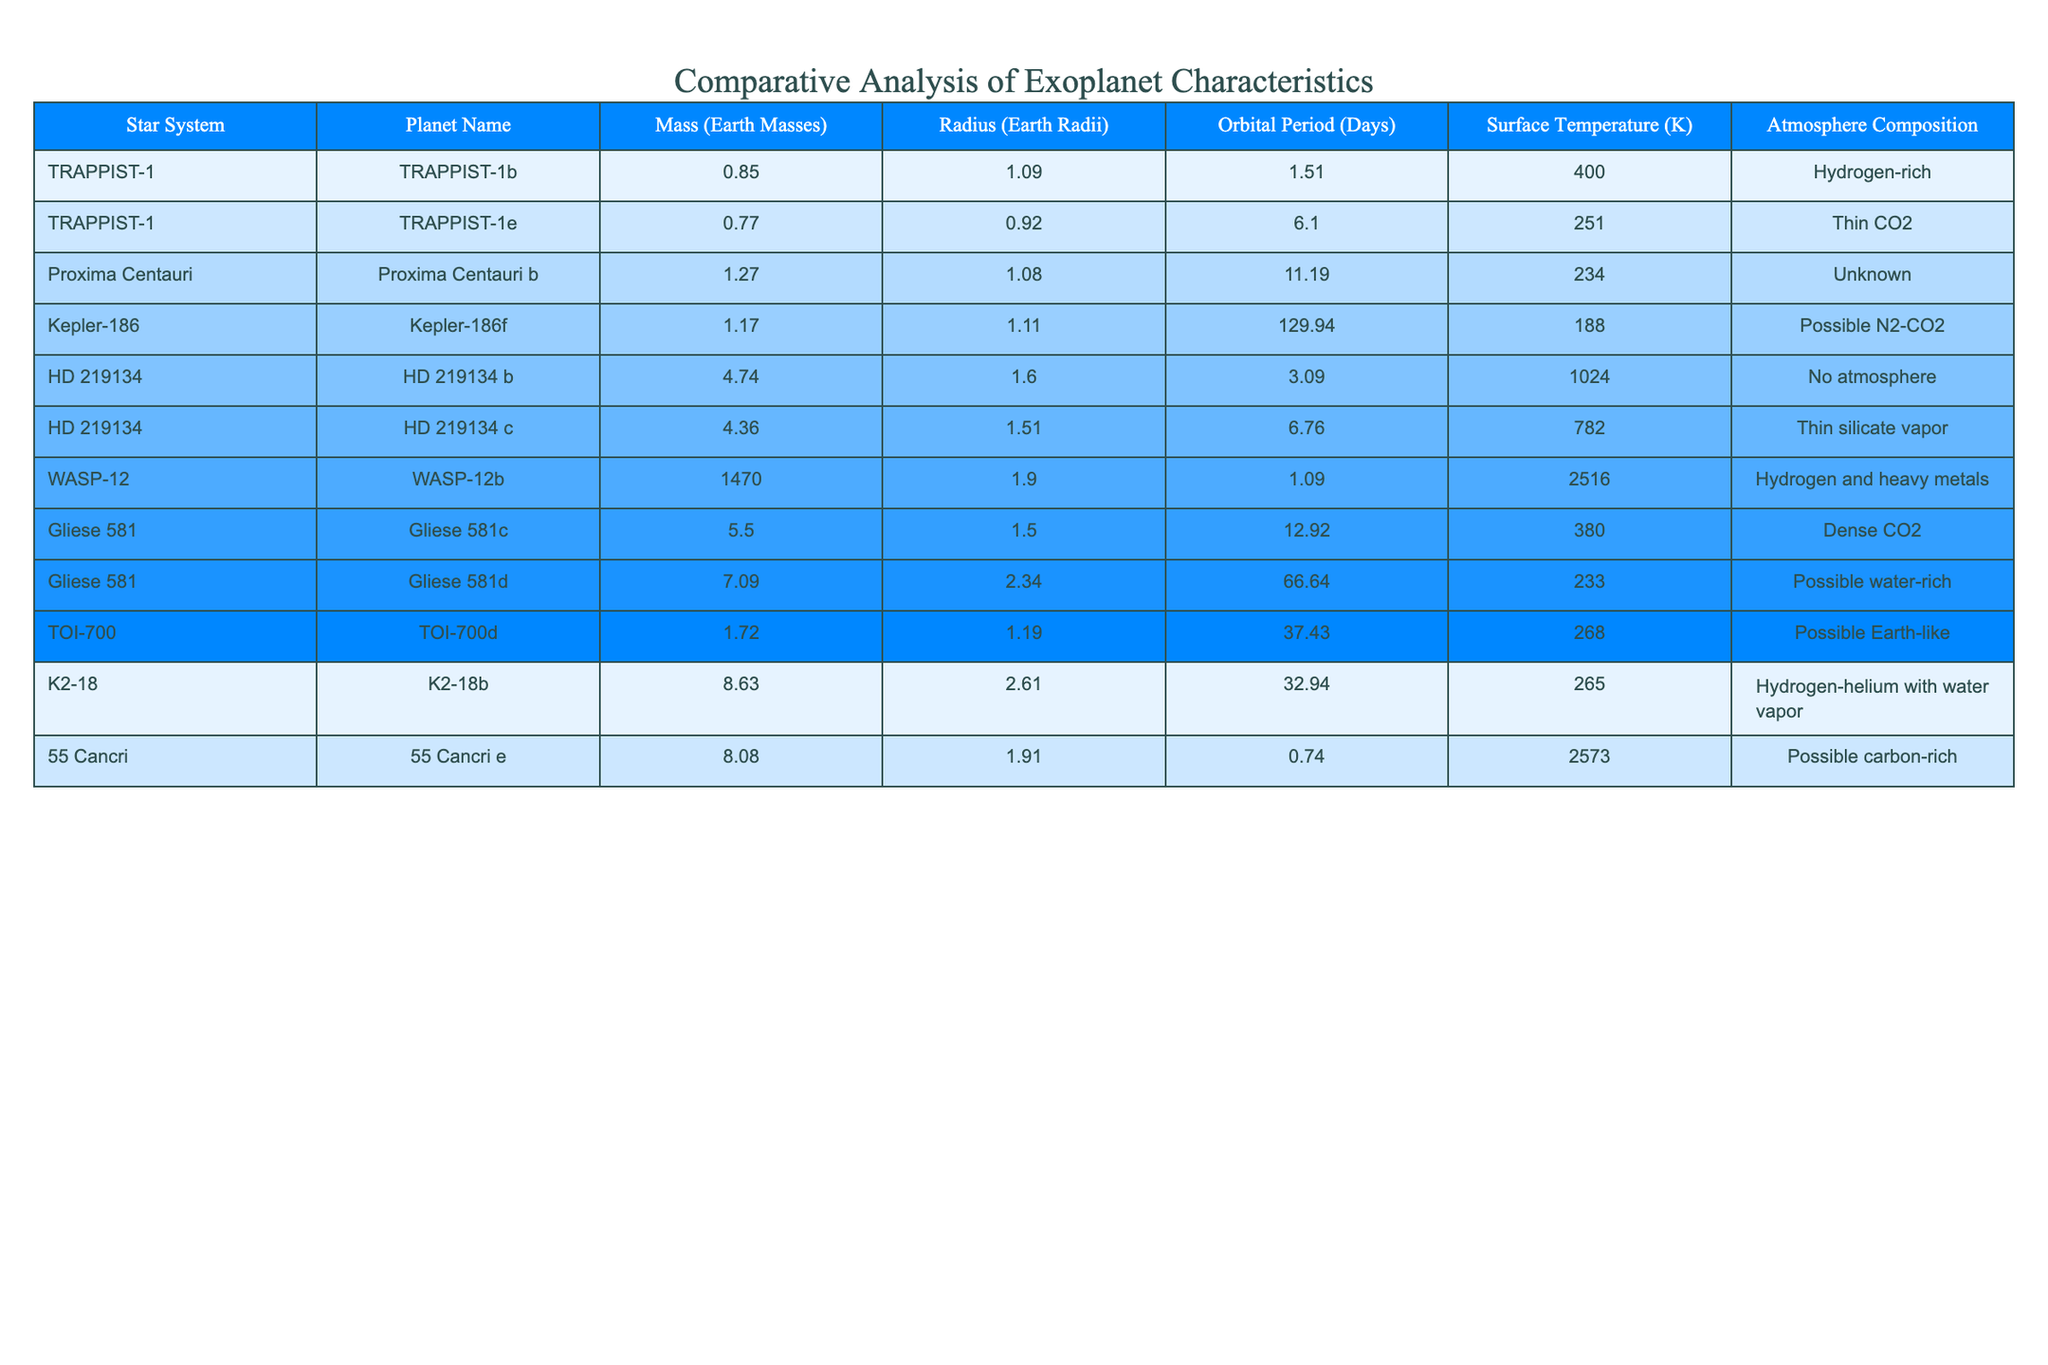What is the mass of Kepler-186f in Earth masses? The table lists the mass of Kepler-186f, which is found in the column labeled "Mass (Earth Masses)." The value corresponding to Kepler-186f is 1.17.
Answer: 1.17 What planet has the highest surface temperature? By examining the "Surface Temperature (K)" column in the table, we can see that the highest value is 2516 K, which corresponds to WASP-12b.
Answer: WASP-12b How many planets have a mass greater than 5 Earth masses? Counting the planets listed in the "Mass (Earth Masses)" column reveals that Gliese 581c, Gliese 581d, K2-18b, and 55 Cancri e all have mass values greater than 5, totaling 4 planets.
Answer: 4 What is the average orbital period of the planets listed? To find the average orbital period, we need to sum the "Orbital Period (Days)" values (1.51 + 6.10 + 11.19 + 129.94 + 3.09 + 6.76 + 1.09 + 12.92 + 66.64 + 37.43 + 0.74) and divide by the number of planets (11). The total is 275.97, and the average is 275.97 / 11 = 25.09 days.
Answer: 25.09 days Do all the planets in the HD 219134 system have a thick atmosphere? Looking at the "Atmosphere Composition" column for the HD 219134 b and c entries, we find that both have either no atmosphere or a thin atmosphere (silicate vapor), indicating they do not have a thick atmosphere.
Answer: No Which planet has the longest orbital period? The "Orbital Period (Days)" column reveals that Kepler-186f has the longest period at 129.94 days.
Answer: Kepler-186f What is the difference in surface temperature between TRAPPIST-1b and TRAPPIST-1e? The surface temperature for TRAPPIST-1b is 400 K and for TRAPPIST-1e is 251 K. The difference is 400 - 251 = 149 K.
Answer: 149 K Is there a planet with no atmosphere, and if so, which one? By checking the "Atmosphere Composition," we see that HD 219134 b has "No atmosphere."
Answer: Yes, HD 219134 b What are the compositions of the atmospheres of the two planets in the Gliese 581 system? The table shows that Gliese 581c has a "Dense CO2" atmosphere and Gliese 581d has a "Possible water-rich" atmosphere.
Answer: Dense CO2 and Possible water-rich How many planets have a surface temperature below 300 K? The surface temperatures below this threshold are for Proxima Centauri b, Kepler-186f, Gliese 581d, TOI-700d, K2-18b, and 55 Cancri e. Counting these gives a total of 6 planets.
Answer: 6 